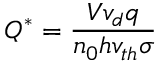Convert formula to latex. <formula><loc_0><loc_0><loc_500><loc_500>Q ^ { * } = \frac { V v _ { d } q } { n _ { 0 } h v _ { t h } \sigma }</formula> 